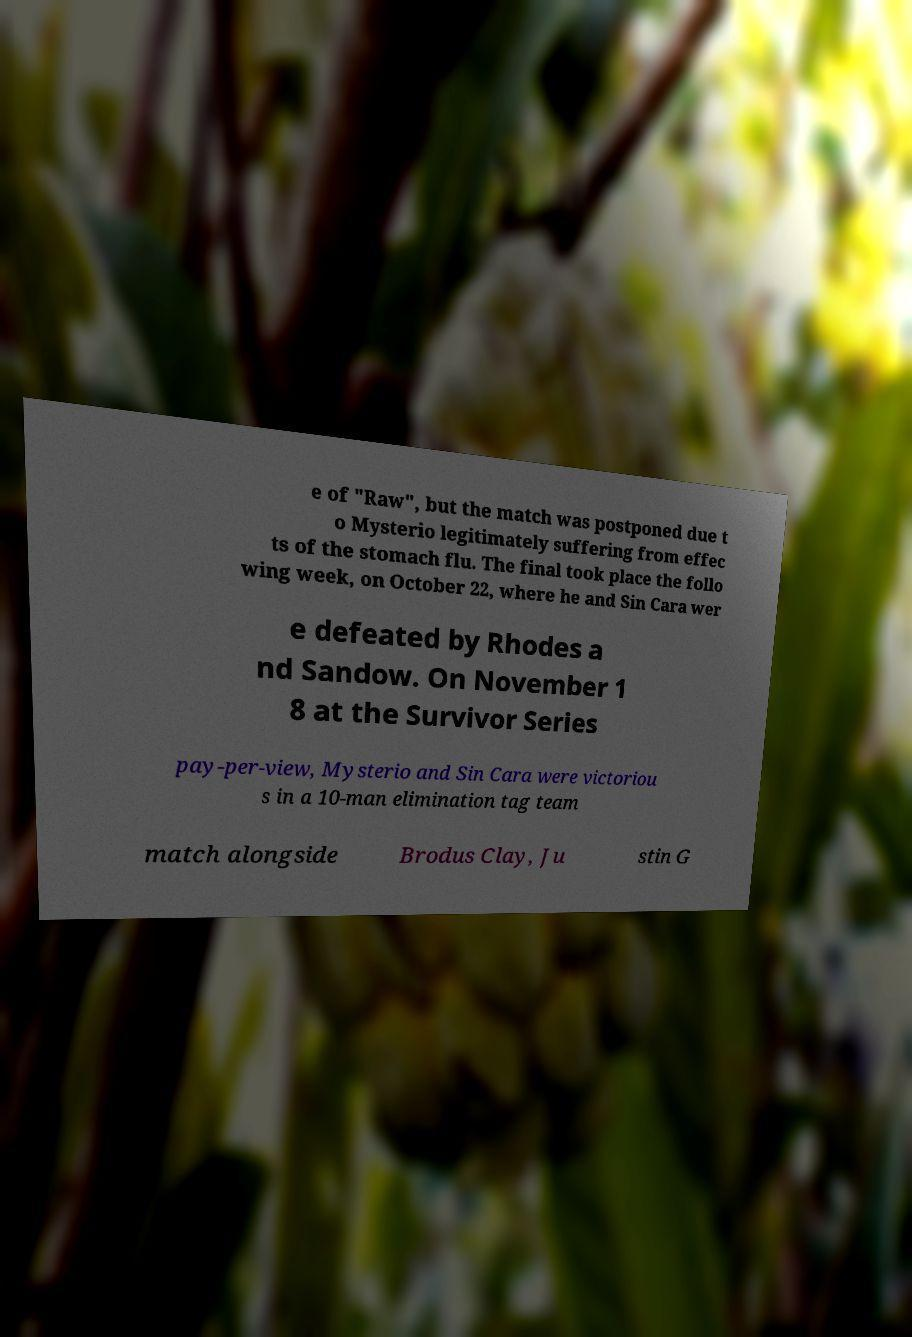Could you assist in decoding the text presented in this image and type it out clearly? e of "Raw", but the match was postponed due t o Mysterio legitimately suffering from effec ts of the stomach flu. The final took place the follo wing week, on October 22, where he and Sin Cara wer e defeated by Rhodes a nd Sandow. On November 1 8 at the Survivor Series pay-per-view, Mysterio and Sin Cara were victoriou s in a 10-man elimination tag team match alongside Brodus Clay, Ju stin G 